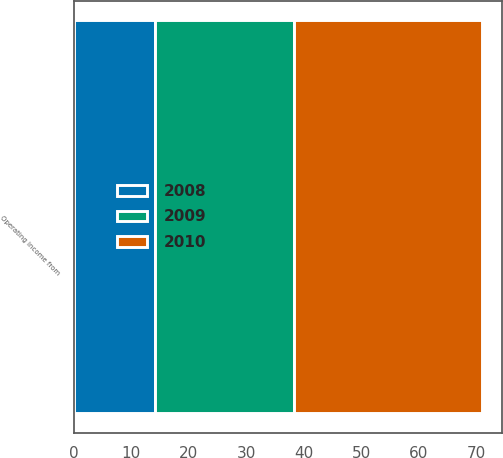<chart> <loc_0><loc_0><loc_500><loc_500><stacked_bar_chart><ecel><fcel>Operating income from<nl><fcel>2010<fcel>32.6<nl><fcel>2008<fcel>14.1<nl><fcel>2009<fcel>24.2<nl></chart> 